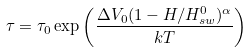Convert formula to latex. <formula><loc_0><loc_0><loc_500><loc_500>\tau = \tau _ { 0 } \exp \left ( \frac { \Delta V _ { 0 } ( 1 - H / H ^ { 0 } _ { s w } ) ^ { \alpha } } { k T } \right )</formula> 